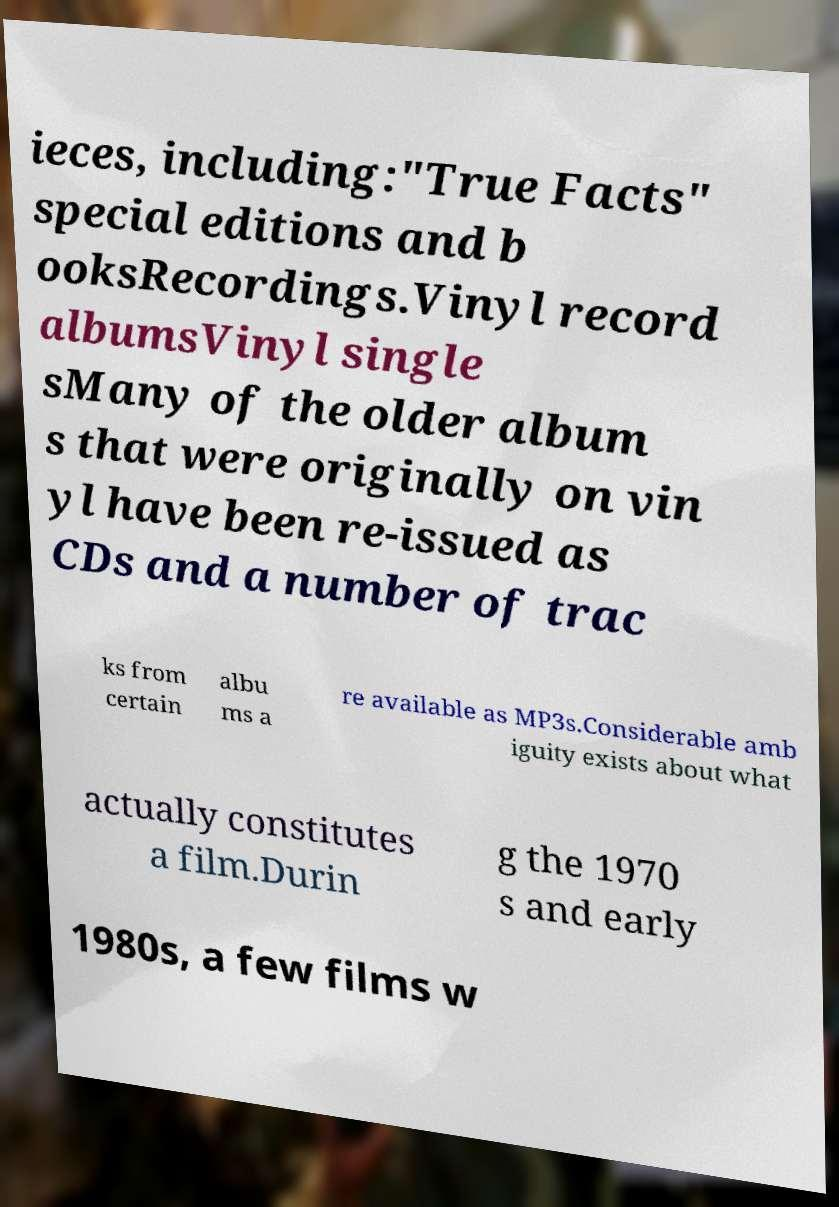I need the written content from this picture converted into text. Can you do that? ieces, including:"True Facts" special editions and b ooksRecordings.Vinyl record albumsVinyl single sMany of the older album s that were originally on vin yl have been re-issued as CDs and a number of trac ks from certain albu ms a re available as MP3s.Considerable amb iguity exists about what actually constitutes a film.Durin g the 1970 s and early 1980s, a few films w 